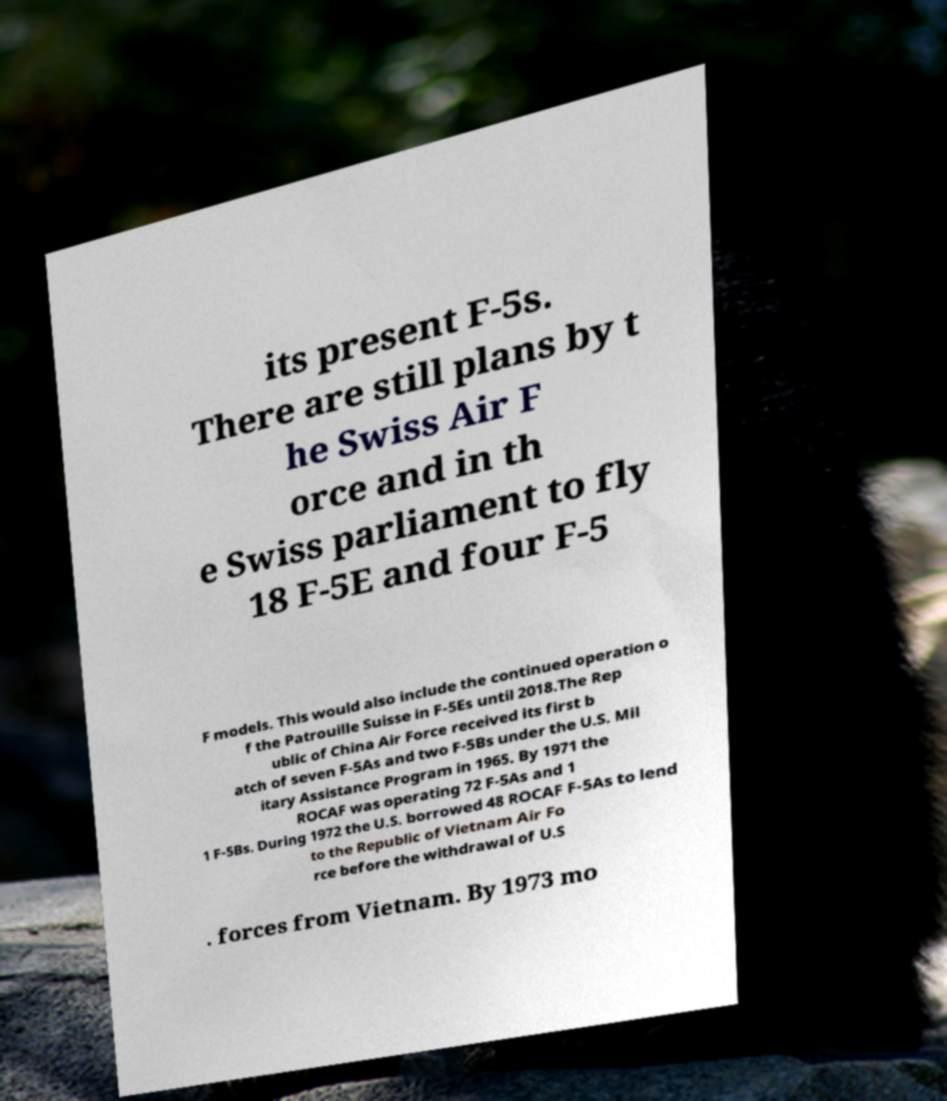Could you extract and type out the text from this image? its present F-5s. There are still plans by t he Swiss Air F orce and in th e Swiss parliament to fly 18 F-5E and four F-5 F models. This would also include the continued operation o f the Patrouille Suisse in F-5Es until 2018.The Rep ublic of China Air Force received its first b atch of seven F-5As and two F-5Bs under the U.S. Mil itary Assistance Program in 1965. By 1971 the ROCAF was operating 72 F-5As and 1 1 F-5Bs. During 1972 the U.S. borrowed 48 ROCAF F-5As to lend to the Republic of Vietnam Air Fo rce before the withdrawal of U.S . forces from Vietnam. By 1973 mo 